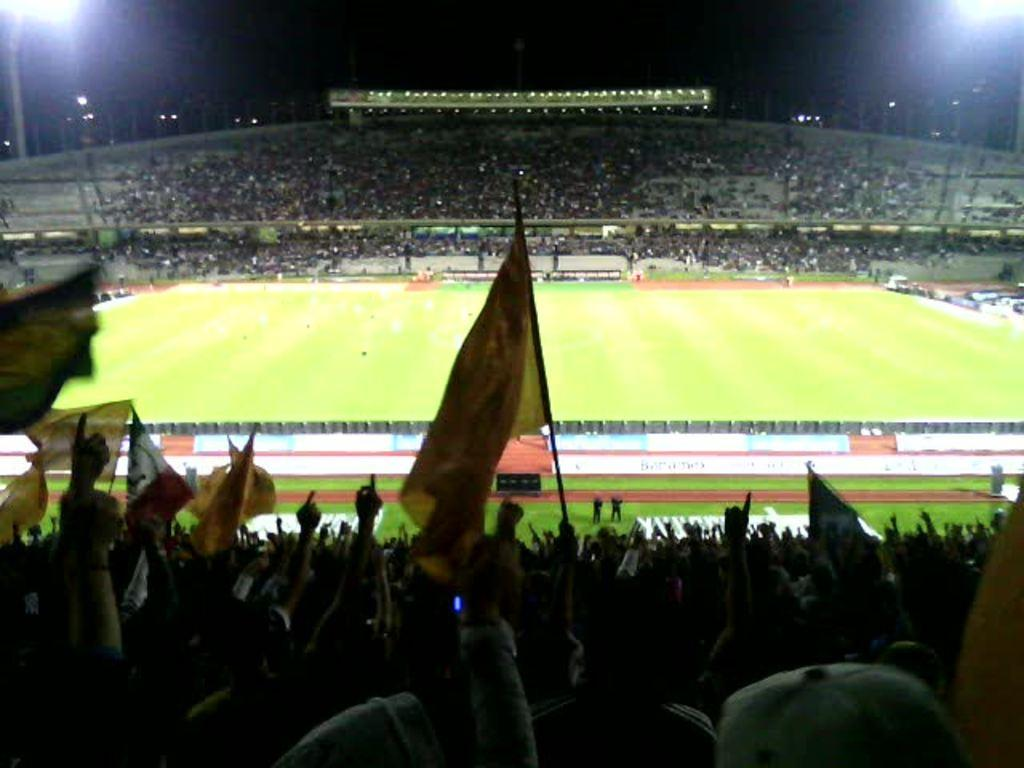Where was the image taken? The image was taken in a stadium. What can be seen in the image besides the stadium? There is a crowd in the image, and they are sitting and holding flags. What is visible in the background of the image? There is a playground and poles in the background of the image. How would you describe the lighting in the image? The sky is dark in the image. What type of bucket is being used by the crowd in the image? There is no bucket present in the image; the crowd is holding flags. What kind of quilt is draped over the playground in the background? There is no quilt visible in the image; only a playground and poles are present in the background. 